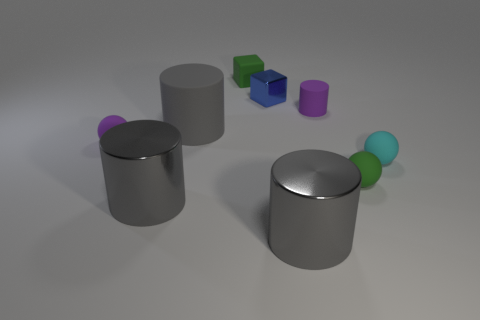Subtract all blue blocks. How many gray cylinders are left? 3 Subtract 1 cylinders. How many cylinders are left? 3 Subtract all cylinders. How many objects are left? 5 Subtract 0 purple cubes. How many objects are left? 9 Subtract all big gray objects. Subtract all small green objects. How many objects are left? 4 Add 5 cubes. How many cubes are left? 7 Add 4 big gray metallic objects. How many big gray metallic objects exist? 6 